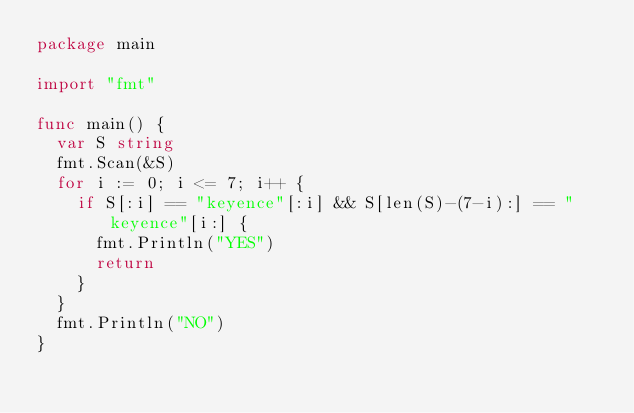Convert code to text. <code><loc_0><loc_0><loc_500><loc_500><_Go_>package main

import "fmt"

func main() {
	var S string
	fmt.Scan(&S)
	for i := 0; i <= 7; i++ {
		if S[:i] == "keyence"[:i] && S[len(S)-(7-i):] == "keyence"[i:] {
			fmt.Println("YES")
			return
		}
	}
	fmt.Println("NO")
}
</code> 